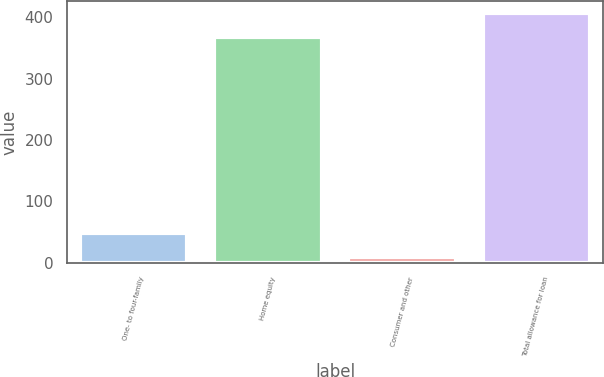<chart> <loc_0><loc_0><loc_500><loc_500><bar_chart><fcel>One- to four-family<fcel>Home equity<fcel>Consumer and other<fcel>Total allowance for loan<nl><fcel>49.4<fcel>367<fcel>10<fcel>406.4<nl></chart> 